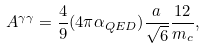Convert formula to latex. <formula><loc_0><loc_0><loc_500><loc_500>A ^ { \gamma \gamma } = \frac { 4 } { 9 } ( 4 \pi \alpha _ { Q E D } ) \frac { a } { \sqrt { 6 } } \frac { 1 2 } { m _ { c } } ,</formula> 